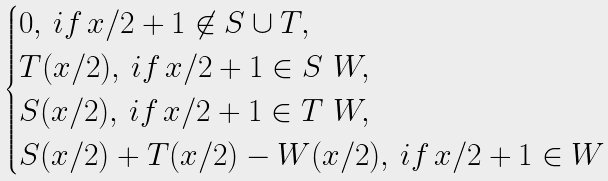<formula> <loc_0><loc_0><loc_500><loc_500>\begin{cases} 0 , \, i f \, x / 2 + 1 \not \in S \cup T , \\ T ( x / 2 ) , \, i f \, x / 2 + 1 \in S \ W , \\ S ( x / 2 ) , \, i f \, x / 2 + 1 \in T \ W , \\ S ( x / 2 ) + T ( x / 2 ) - W ( x / 2 ) , \, i f \, x / 2 + 1 \in W \end{cases}</formula> 